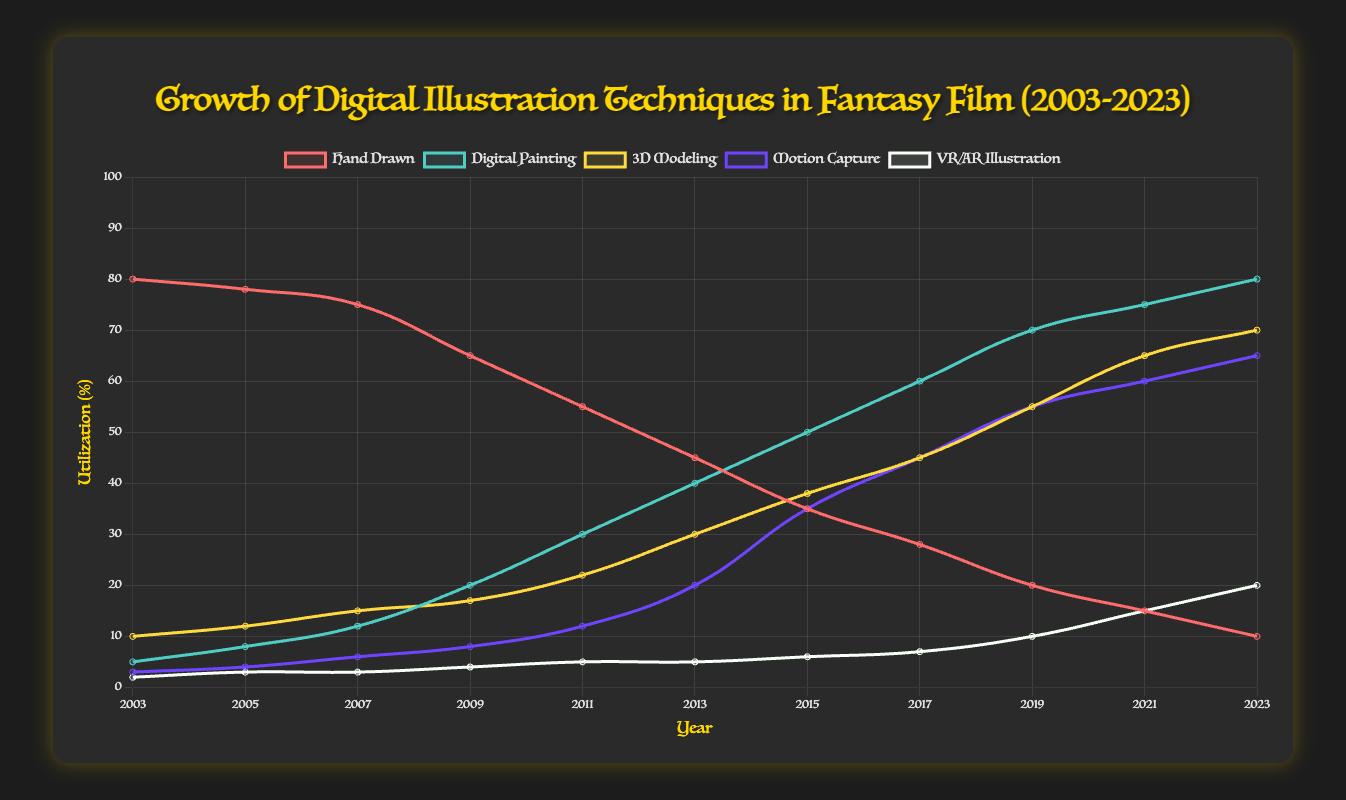How has the utilization of hand-drawn techniques changed over the last 20 years? To find the change in utilization of hand-drawn techniques, we look at the data for hand-drawn techniques in 2003 and 2023. The utilization decreased from 80% in 2003 to 10% in 2023. This shows a reduction of 70%.
Answer: It has decreased by 70% Between which years did digital painting techniques see the most significant growth in utilization? To determine the years with the most significant growth in digital painting, we look for the largest increase between two consecutive years in the dataset for digital painting. From 2003 to 2023, the largest increase occurred between 2009 (20%) and 2011 (30%), which is an increase of 10%.
Answer: Between 2009 and 2011 Which technique had the highest utilization in 2023? By examining the data for 2023, Digital Painting had the highest utilization rate at 80%, which is more than Hand Drawn (10%), 3D Modeling (70%), Motion Capture (65%), and VR/AR Illustration (20%).
Answer: Digital Painting What is the average utilization of 3D Modeling techniques over the last 20 years? To compute the average utilization of 3D Modeling, sum the values from 2003 to 2023 (10 + 12 + 15 + 17 + 22 + 30 + 38 + 45 + 55 + 65 + 70) which equals 379, and then divide by the number of data points (11 years). The average utilization is 379 / 11 ≈ 34.45.
Answer: ≈ 34.45% How does the utilization of VR/AR Illustration in 2023 compare to 2003? By comparing the VR/AR Illustration utilization in 2023 (20%) and 2003 (2%), it shows an increase of 18%.
Answer: It increased by 18% Which technique showed the most constant growth over the period? Comparing the slopes of the lines for each technique can show which one had the most gradual or constant increase. 3D Modeling and Digital Painting both show fairly constant linear increases, but Digital Painting's growth rate appears more linear and consistent throughout the years.
Answer: Digital Painting Compare the utilization rates of Motion Capture and 3D Modeling in 2021. Which is higher and by how much? In 2021, the utilization rates are 60% for Motion Capture and 65% for 3D Modeling. 3D Modeling has a higher utilization rate by 5%.
Answer: 3D Modeling by 5% What is the total utilization percentage of all techniques combined in 2023? To find the total utilization percentage, sum all the values for 2023 (10 for Hand Drawn + 80 for Digital Painting + 70 for 3D Modeling + 65 for Motion Capture + 20 for VR/AR Illustration), which equals 245%.
Answer: 245% How has the utilization of Hand Drawn changed relative to Digital Painting between 2003 and 2023? In 2003, Hand Drawn utilization was 80% and Digital Painting was 5%. In 2023, Hand Drawn utilization is 10% and Digital Painting is 80%. Hand Drawn decreased by 70%, while Digital Painting increased by 75%. This shows that Digital Painting increased significantly while Hand Drawn decreased.
Answer: Hand Drawn decreased by 70%, Digital Painting increased by 75% Between 2011 and 2015, which technique experienced the greatest percentage increase? For this period, the percentage changes can be calculated as follows: Hand Drawn (-10% from 55% to 45%), Digital Painting (10% from 30% to 40%), 3D Modeling (8% from 22% to 30%), Motion Capture (8% from 12% to 20%), VR/AR Illustration (0% from 5% to 5%). Digital Painting had the highest increase of 10%.
Answer: Digital Painting 